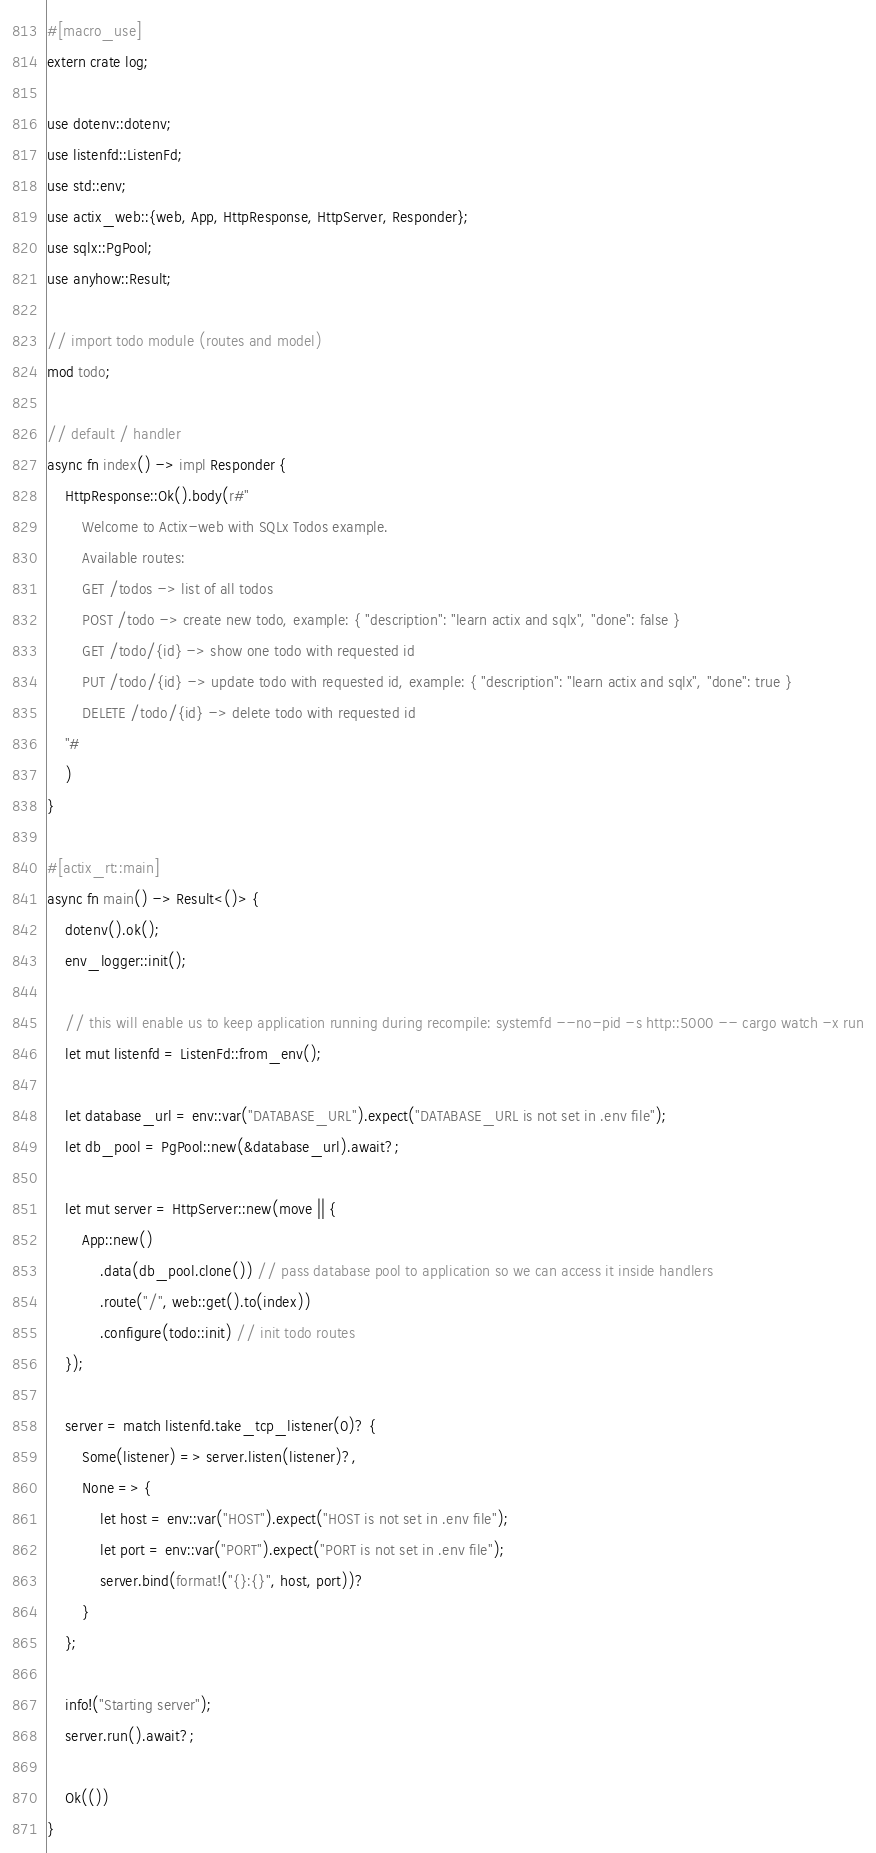<code> <loc_0><loc_0><loc_500><loc_500><_Rust_>#[macro_use]
extern crate log;

use dotenv::dotenv;
use listenfd::ListenFd;
use std::env;
use actix_web::{web, App, HttpResponse, HttpServer, Responder};
use sqlx::PgPool;
use anyhow::Result;

// import todo module (routes and model)
mod todo;

// default / handler
async fn index() -> impl Responder {
    HttpResponse::Ok().body(r#"
        Welcome to Actix-web with SQLx Todos example.
        Available routes:
        GET /todos -> list of all todos
        POST /todo -> create new todo, example: { "description": "learn actix and sqlx", "done": false }
        GET /todo/{id} -> show one todo with requested id
        PUT /todo/{id} -> update todo with requested id, example: { "description": "learn actix and sqlx", "done": true }
        DELETE /todo/{id} -> delete todo with requested id
    "#
    )
}

#[actix_rt::main]
async fn main() -> Result<()> {
    dotenv().ok();
    env_logger::init();

    // this will enable us to keep application running during recompile: systemfd --no-pid -s http::5000 -- cargo watch -x run
    let mut listenfd = ListenFd::from_env();

    let database_url = env::var("DATABASE_URL").expect("DATABASE_URL is not set in .env file");
    let db_pool = PgPool::new(&database_url).await?;

    let mut server = HttpServer::new(move || {
        App::new()
            .data(db_pool.clone()) // pass database pool to application so we can access it inside handlers
            .route("/", web::get().to(index))
            .configure(todo::init) // init todo routes
    });

    server = match listenfd.take_tcp_listener(0)? {
        Some(listener) => server.listen(listener)?,
        None => {
            let host = env::var("HOST").expect("HOST is not set in .env file");
            let port = env::var("PORT").expect("PORT is not set in .env file");
            server.bind(format!("{}:{}", host, port))?
        }
    };

    info!("Starting server");
    server.run().await?;

    Ok(())
}</code> 